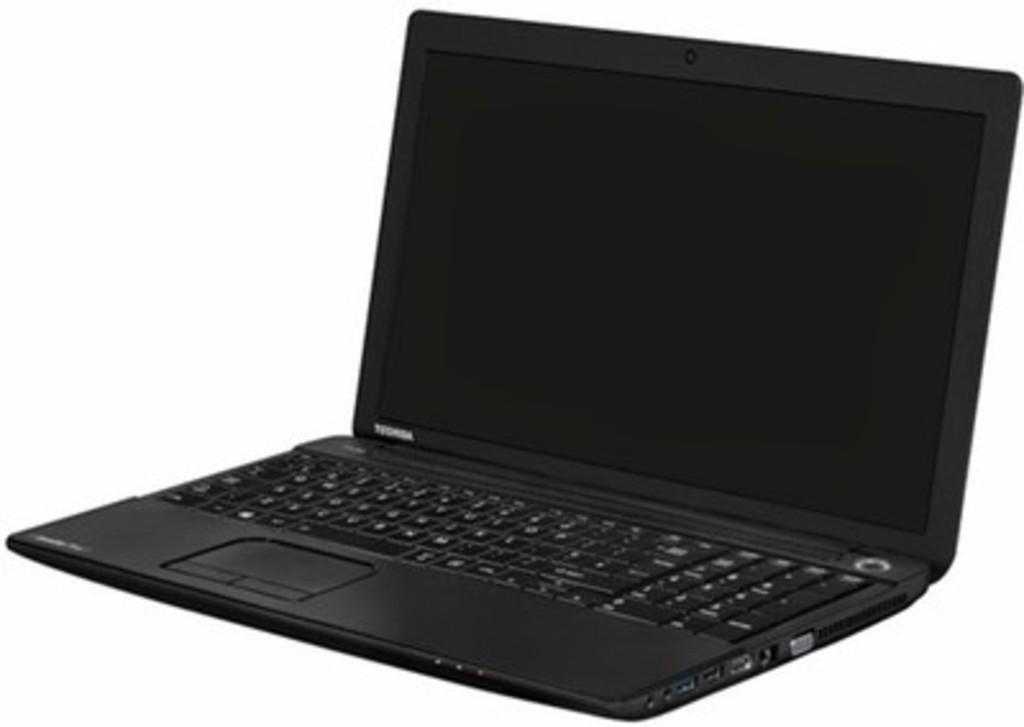<image>
Describe the image concisely. A Toshiba laptop sits on a white background powered down. 